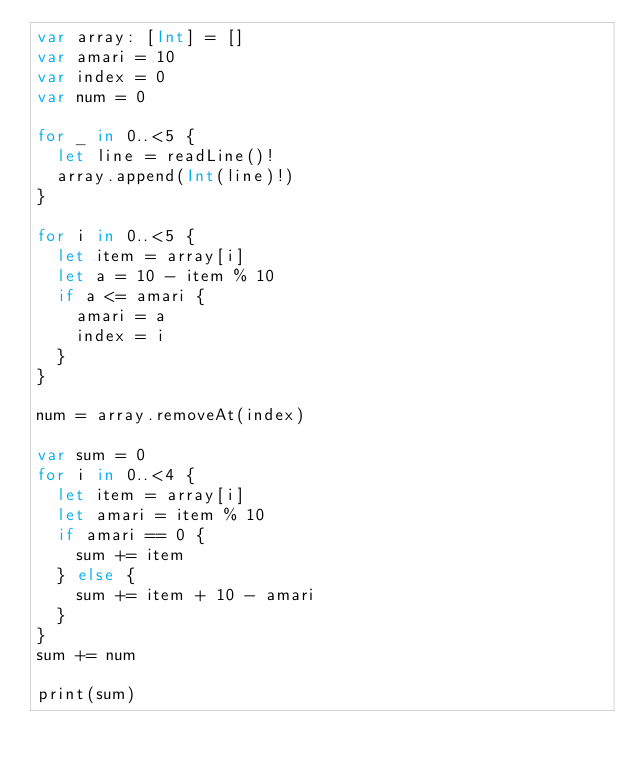Convert code to text. <code><loc_0><loc_0><loc_500><loc_500><_Swift_>var array: [Int] = []
var amari = 10
var index = 0
var num = 0

for _ in 0..<5 {
  let line = readLine()!
  array.append(Int(line)!)
}

for i in 0..<5 {
  let item = array[i]
  let a = 10 - item % 10
  if a <= amari {
    amari = a
    index = i
  }
}

num = array.removeAt(index)

var sum = 0
for i in 0..<4 {
  let item = array[i]
  let amari = item % 10
  if amari == 0 {
    sum += item
  } else {
    sum += item + 10 - amari
  }
}
sum += num

print(sum)
</code> 